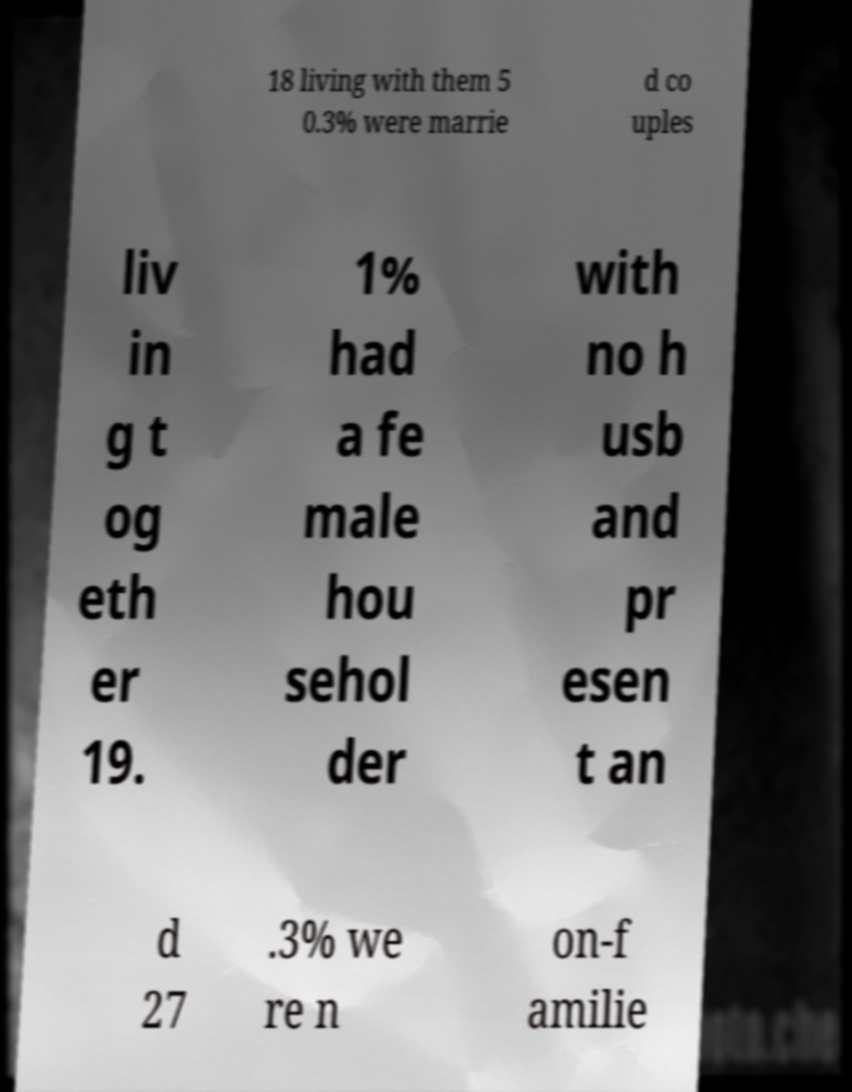There's text embedded in this image that I need extracted. Can you transcribe it verbatim? 18 living with them 5 0.3% were marrie d co uples liv in g t og eth er 19. 1% had a fe male hou sehol der with no h usb and pr esen t an d 27 .3% we re n on-f amilie 